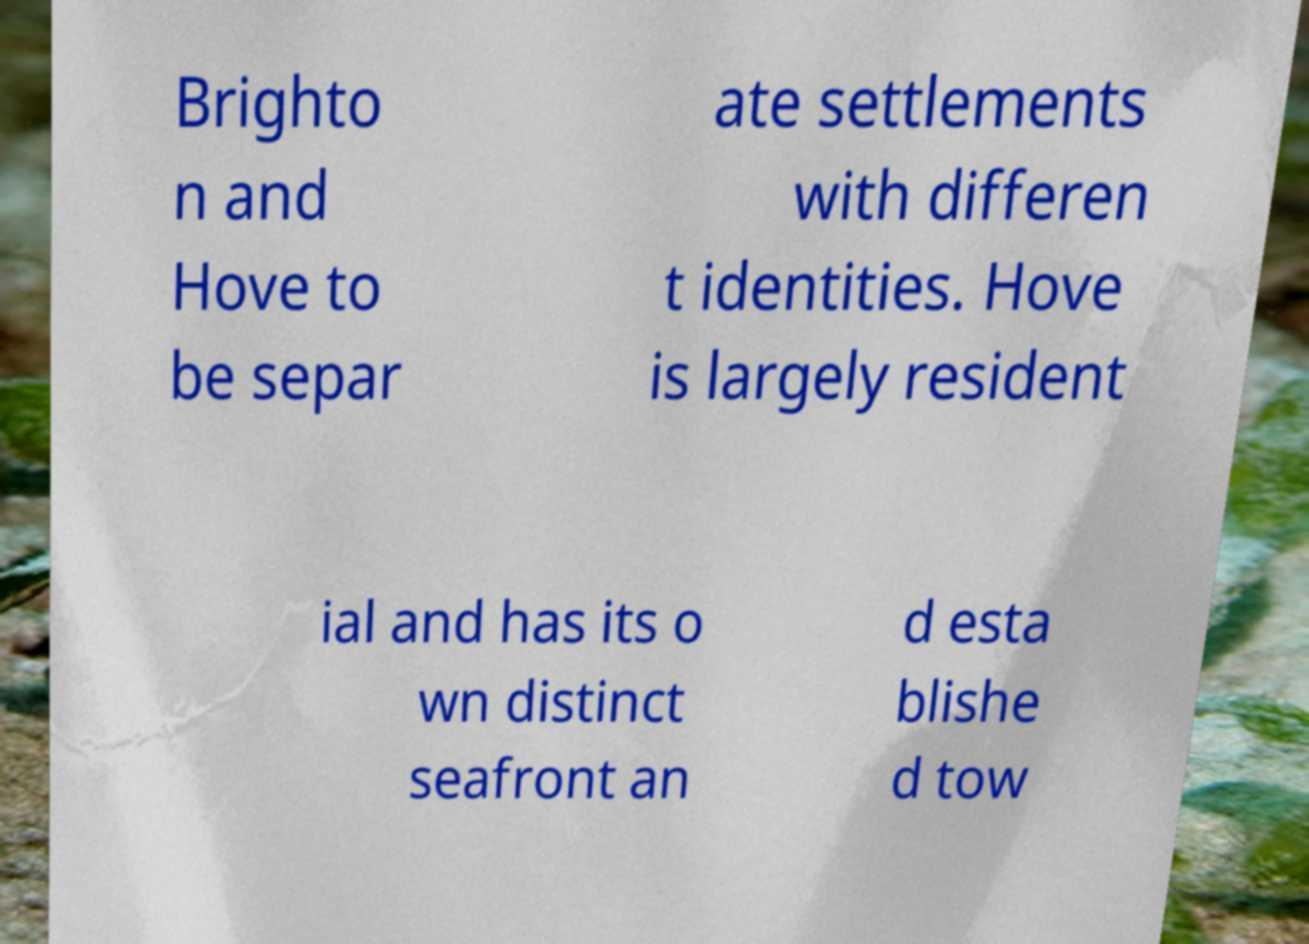Please identify and transcribe the text found in this image. Brighto n and Hove to be separ ate settlements with differen t identities. Hove is largely resident ial and has its o wn distinct seafront an d esta blishe d tow 